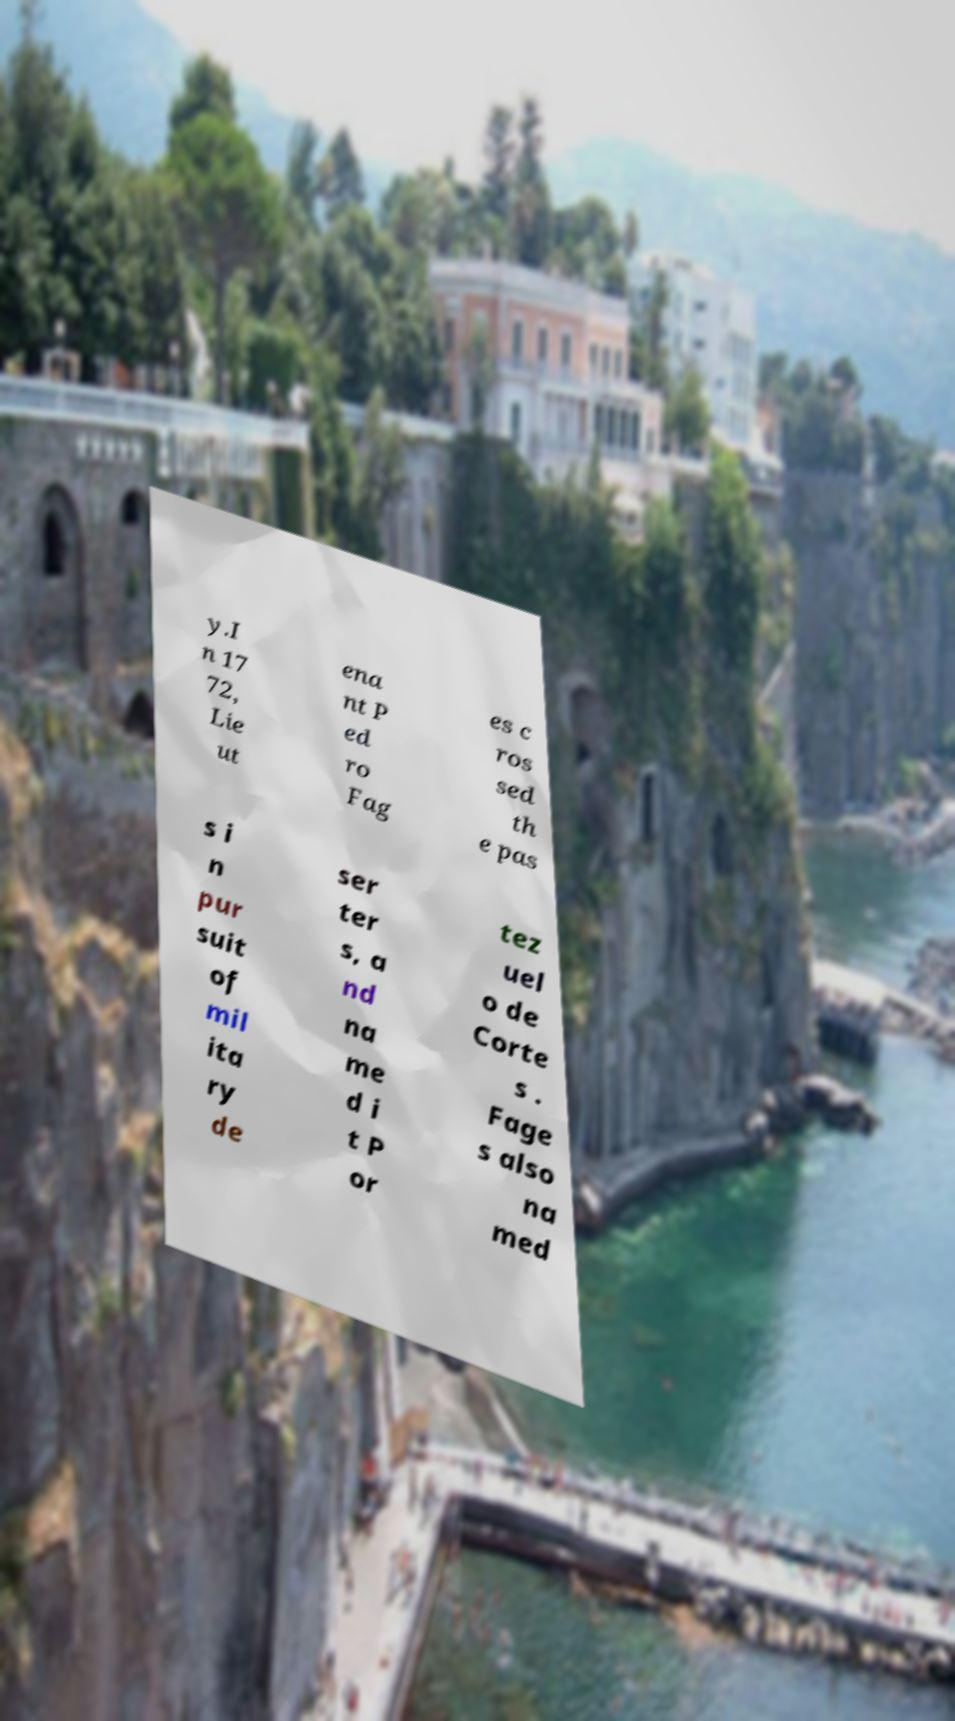Can you read and provide the text displayed in the image?This photo seems to have some interesting text. Can you extract and type it out for me? y.I n 17 72, Lie ut ena nt P ed ro Fag es c ros sed th e pas s i n pur suit of mil ita ry de ser ter s, a nd na me d i t P or tez uel o de Corte s . Fage s also na med 